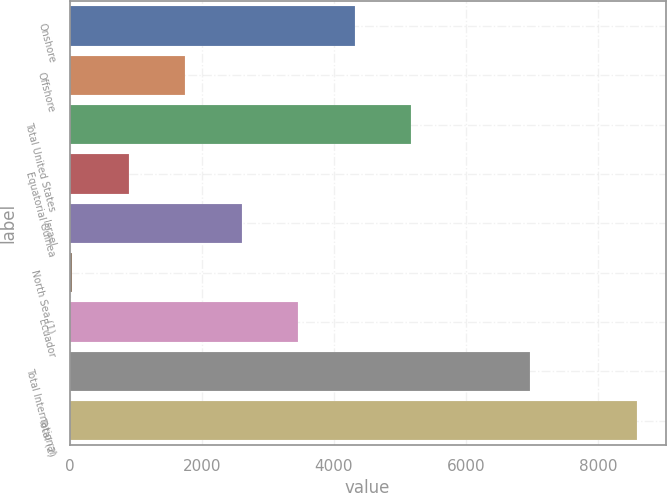Convert chart to OTSL. <chart><loc_0><loc_0><loc_500><loc_500><bar_chart><fcel>Onshore<fcel>Offshore<fcel>Total United States<fcel>Equatorial Guinea<fcel>Israel<fcel>North Sea (1)<fcel>Ecuador<fcel>Total International<fcel>Total (2)<nl><fcel>4320<fcel>1754.4<fcel>5175.2<fcel>899.2<fcel>2609.6<fcel>44<fcel>3464.8<fcel>6972<fcel>8596<nl></chart> 